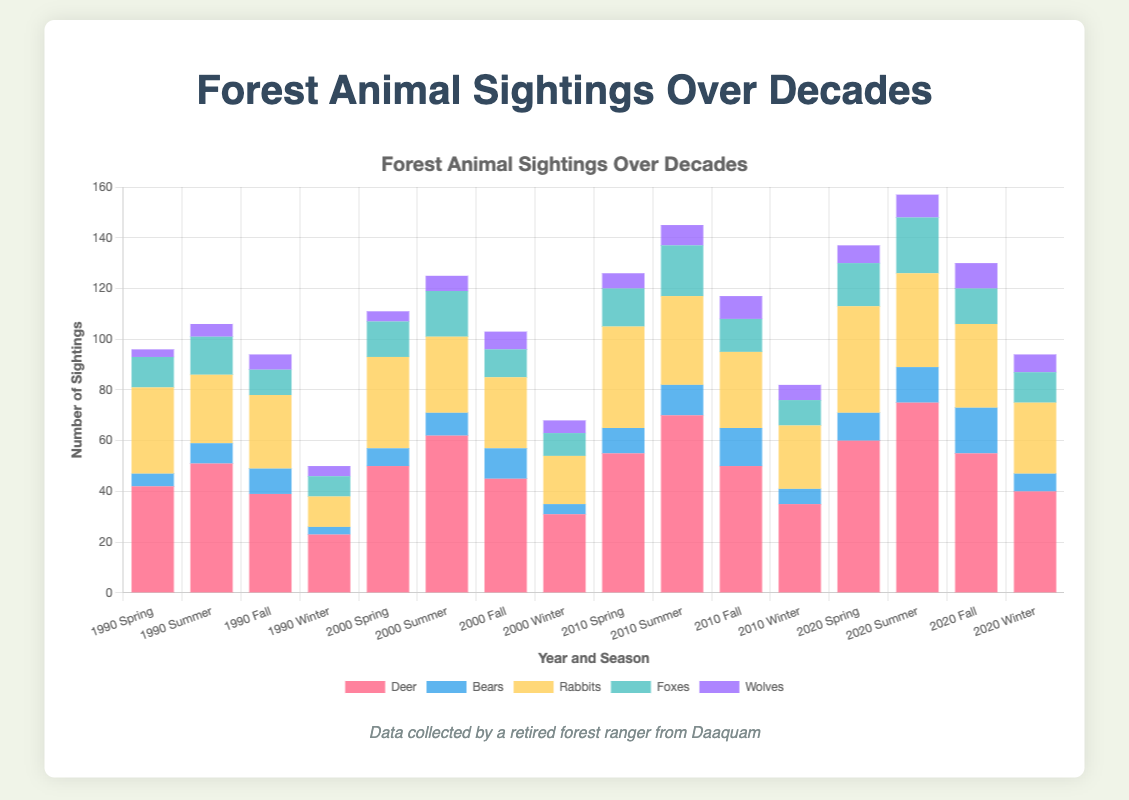Which decade had the highest total number of deer sightings in the summer season? To find the answer, sum the deer sightings in the summer season for each decade: 1990: 51, 2000: 62, 2010: 70, and 2020: 75. 2020 has the highest total number of deer sightings in the summer season.
Answer: 2020 In which year and season were bear sightings the highest? Look for the highest number of bear sightings across all years and seasons: bear sightings are highest in Fall 2020 with 18 sightings.
Answer: 2020 Fall What is the average number of wolves sighted in winter across all decades? Calculate the average number of winter wolf sightings: (4 in 1990 + 5 in 2000 + 6 in 2010 + 7 in 2020) / 4 = 22 / 4 = 5.5.
Answer: 5.5 How do the total rabbit sightings in 1990 compare to those in 2020? Sum up rabbit sightings for each year and compare: 1990: 34 + 27 + 29 + 12 = 102, 2020: 42 + 37 + 33 + 28 = 140. 2020 has more rabbit sightings than 1990.
Answer: 2020 has more Which season consistently has the least number of deer sightings across all decades? Identify the season with the smallest number of deer sightings in each decade: Winter sightings are the least for 1990 (23), 2000 (31), 2010 (35), and 2020 (40).
Answer: Winter In 2010, which animal had the second highest number of sightings during the spring season? For Spring 2010, the numbers are: deer (55), bears (10), rabbits (40), foxes (15), wolves (6). Rabbits have the second highest sightings.
Answer: Rabbits What is the total number of sightings for foxes in all seasons in 2000? Sum fox sightings for all seasons in 2000: 14 (Spring) + 18 (Summer) + 11 (Fall) + 9 (Winter) = 52.
Answer: 52 How do the total number of bear sightings in 1990 compare to 2010? Sum bear sightings for each year and compare: 1990: 5 + 8 + 10 + 3 = 26, 2010: 10 + 12 + 15 + 6 = 43. 2010 has more bear sightings than 1990.
Answer: 2010 has more 